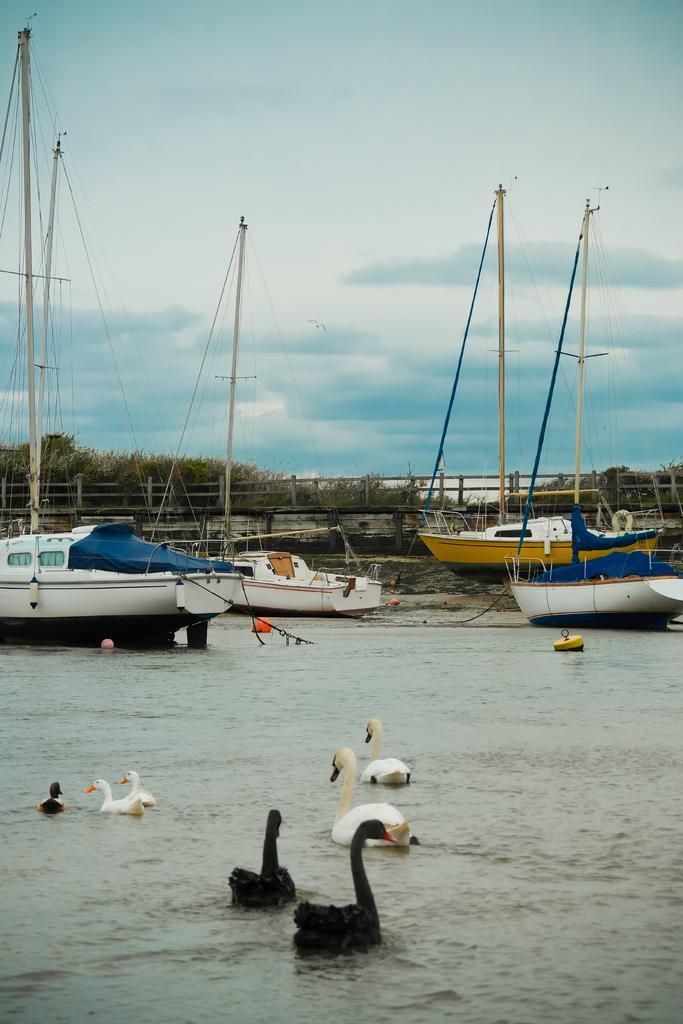Describe this image in one or two sentences. In this image we can see birds and ships are on the water. In the background we can see ships on the ground, poles, fence, objects, trees and clouds in the sky. 